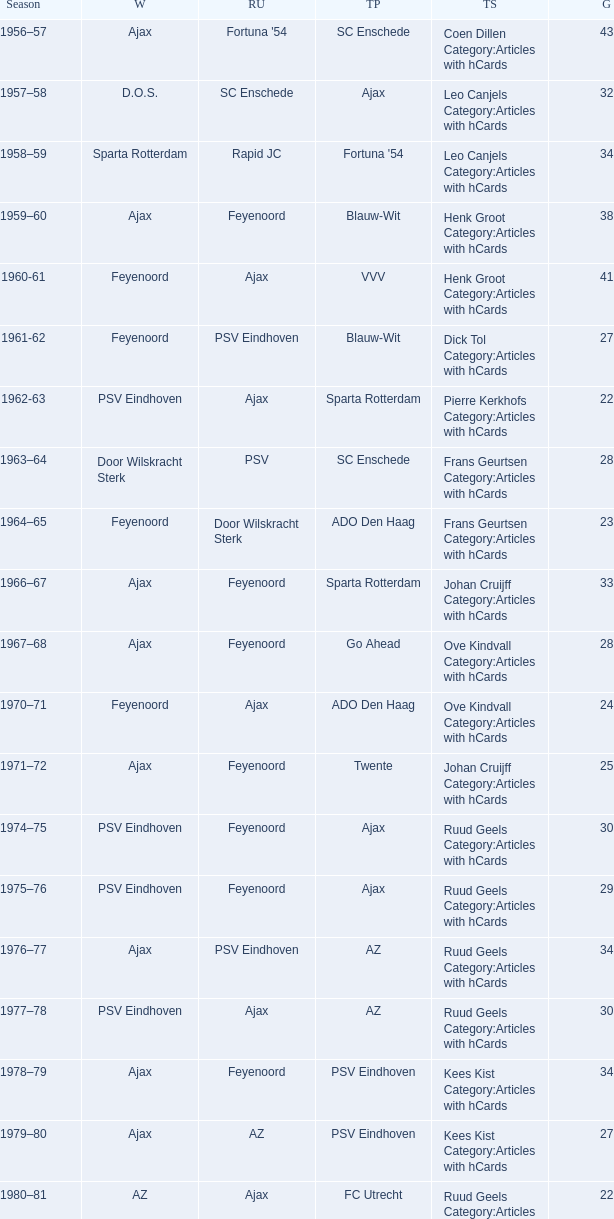When nac breda came in third place and psv eindhoven was the winner who is the top scorer? Klaas-Jan Huntelaar Category:Articles with hCards. 